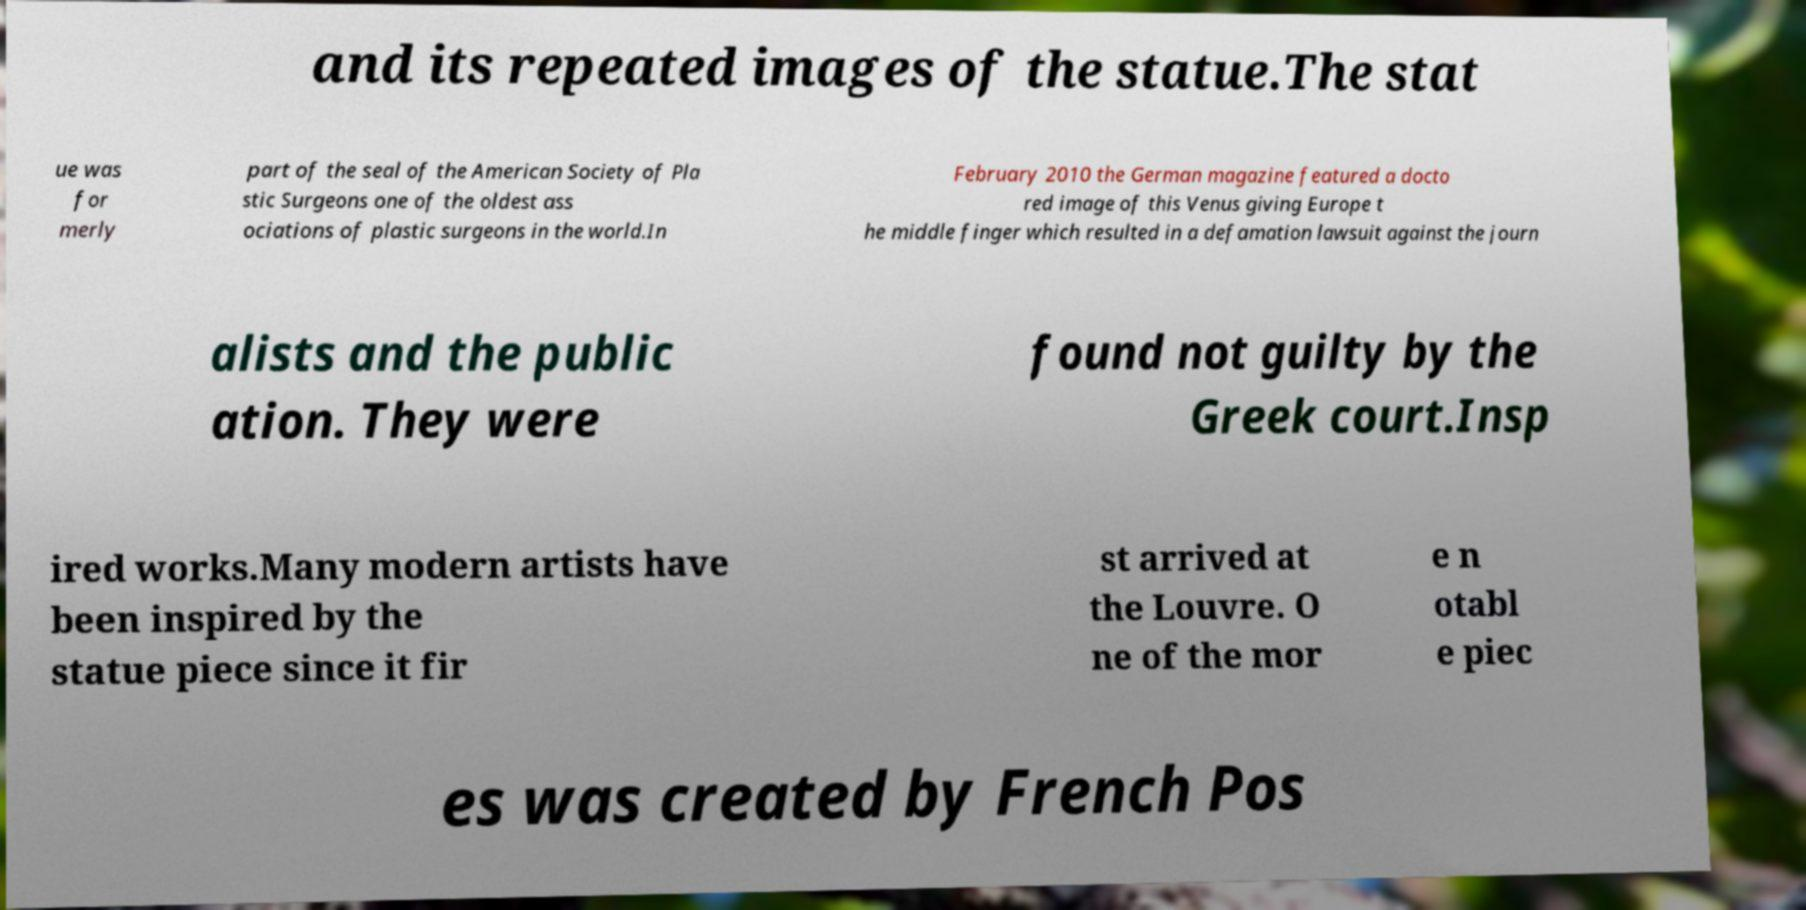Please read and relay the text visible in this image. What does it say? and its repeated images of the statue.The stat ue was for merly part of the seal of the American Society of Pla stic Surgeons one of the oldest ass ociations of plastic surgeons in the world.In February 2010 the German magazine featured a docto red image of this Venus giving Europe t he middle finger which resulted in a defamation lawsuit against the journ alists and the public ation. They were found not guilty by the Greek court.Insp ired works.Many modern artists have been inspired by the statue piece since it fir st arrived at the Louvre. O ne of the mor e n otabl e piec es was created by French Pos 